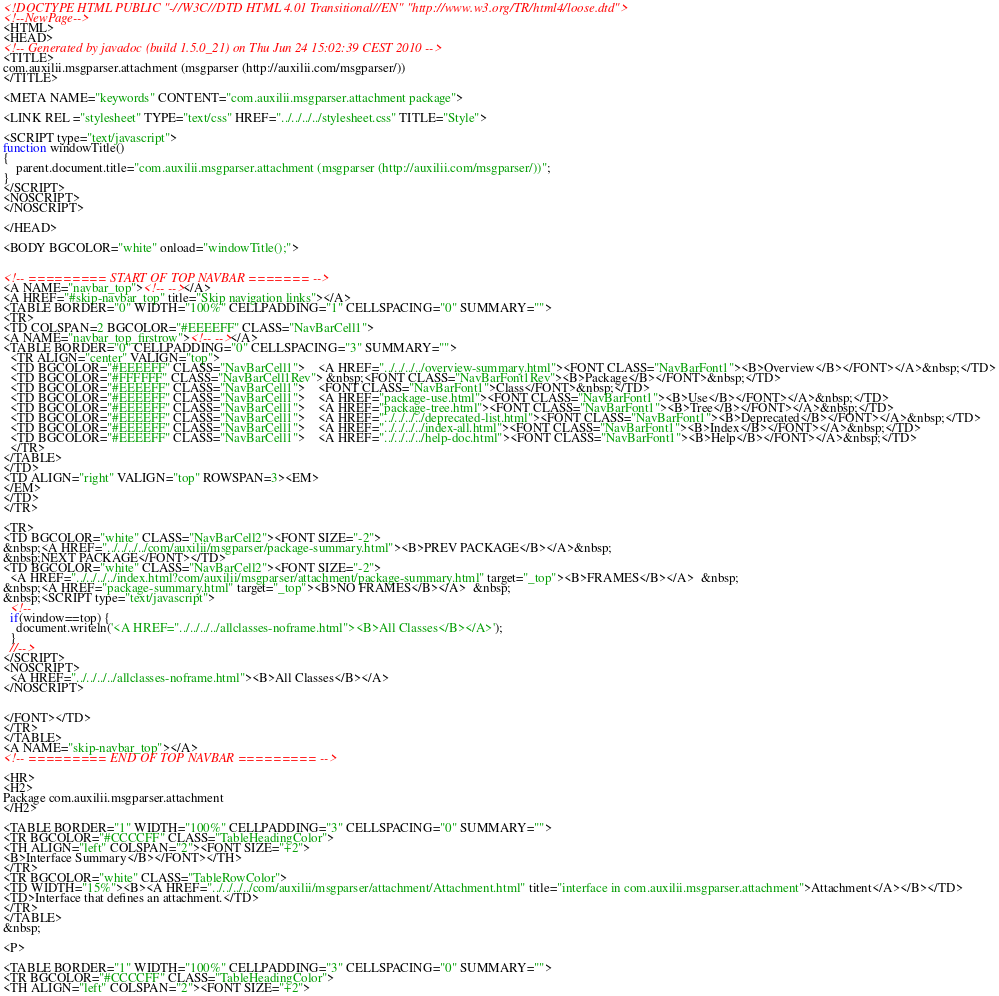<code> <loc_0><loc_0><loc_500><loc_500><_HTML_><!DOCTYPE HTML PUBLIC "-//W3C//DTD HTML 4.01 Transitional//EN" "http://www.w3.org/TR/html4/loose.dtd">
<!--NewPage-->
<HTML>
<HEAD>
<!-- Generated by javadoc (build 1.5.0_21) on Thu Jun 24 15:02:39 CEST 2010 -->
<TITLE>
com.auxilii.msgparser.attachment (msgparser (http://auxilii.com/msgparser/))
</TITLE>

<META NAME="keywords" CONTENT="com.auxilii.msgparser.attachment package">

<LINK REL ="stylesheet" TYPE="text/css" HREF="../../../../stylesheet.css" TITLE="Style">

<SCRIPT type="text/javascript">
function windowTitle()
{
    parent.document.title="com.auxilii.msgparser.attachment (msgparser (http://auxilii.com/msgparser/))";
}
</SCRIPT>
<NOSCRIPT>
</NOSCRIPT>

</HEAD>

<BODY BGCOLOR="white" onload="windowTitle();">


<!-- ========= START OF TOP NAVBAR ======= -->
<A NAME="navbar_top"><!-- --></A>
<A HREF="#skip-navbar_top" title="Skip navigation links"></A>
<TABLE BORDER="0" WIDTH="100%" CELLPADDING="1" CELLSPACING="0" SUMMARY="">
<TR>
<TD COLSPAN=2 BGCOLOR="#EEEEFF" CLASS="NavBarCell1">
<A NAME="navbar_top_firstrow"><!-- --></A>
<TABLE BORDER="0" CELLPADDING="0" CELLSPACING="3" SUMMARY="">
  <TR ALIGN="center" VALIGN="top">
  <TD BGCOLOR="#EEEEFF" CLASS="NavBarCell1">    <A HREF="../../../../overview-summary.html"><FONT CLASS="NavBarFont1"><B>Overview</B></FONT></A>&nbsp;</TD>
  <TD BGCOLOR="#FFFFFF" CLASS="NavBarCell1Rev"> &nbsp;<FONT CLASS="NavBarFont1Rev"><B>Package</B></FONT>&nbsp;</TD>
  <TD BGCOLOR="#EEEEFF" CLASS="NavBarCell1">    <FONT CLASS="NavBarFont1">Class</FONT>&nbsp;</TD>
  <TD BGCOLOR="#EEEEFF" CLASS="NavBarCell1">    <A HREF="package-use.html"><FONT CLASS="NavBarFont1"><B>Use</B></FONT></A>&nbsp;</TD>
  <TD BGCOLOR="#EEEEFF" CLASS="NavBarCell1">    <A HREF="package-tree.html"><FONT CLASS="NavBarFont1"><B>Tree</B></FONT></A>&nbsp;</TD>
  <TD BGCOLOR="#EEEEFF" CLASS="NavBarCell1">    <A HREF="../../../../deprecated-list.html"><FONT CLASS="NavBarFont1"><B>Deprecated</B></FONT></A>&nbsp;</TD>
  <TD BGCOLOR="#EEEEFF" CLASS="NavBarCell1">    <A HREF="../../../../index-all.html"><FONT CLASS="NavBarFont1"><B>Index</B></FONT></A>&nbsp;</TD>
  <TD BGCOLOR="#EEEEFF" CLASS="NavBarCell1">    <A HREF="../../../../help-doc.html"><FONT CLASS="NavBarFont1"><B>Help</B></FONT></A>&nbsp;</TD>
  </TR>
</TABLE>
</TD>
<TD ALIGN="right" VALIGN="top" ROWSPAN=3><EM>
</EM>
</TD>
</TR>

<TR>
<TD BGCOLOR="white" CLASS="NavBarCell2"><FONT SIZE="-2">
&nbsp;<A HREF="../../../../com/auxilii/msgparser/package-summary.html"><B>PREV PACKAGE</B></A>&nbsp;
&nbsp;NEXT PACKAGE</FONT></TD>
<TD BGCOLOR="white" CLASS="NavBarCell2"><FONT SIZE="-2">
  <A HREF="../../../../index.html?com/auxilii/msgparser/attachment/package-summary.html" target="_top"><B>FRAMES</B></A>  &nbsp;
&nbsp;<A HREF="package-summary.html" target="_top"><B>NO FRAMES</B></A>  &nbsp;
&nbsp;<SCRIPT type="text/javascript">
  <!--
  if(window==top) {
    document.writeln('<A HREF="../../../../allclasses-noframe.html"><B>All Classes</B></A>');
  }
  //-->
</SCRIPT>
<NOSCRIPT>
  <A HREF="../../../../allclasses-noframe.html"><B>All Classes</B></A>
</NOSCRIPT>


</FONT></TD>
</TR>
</TABLE>
<A NAME="skip-navbar_top"></A>
<!-- ========= END OF TOP NAVBAR ========= -->

<HR>
<H2>
Package com.auxilii.msgparser.attachment
</H2>

<TABLE BORDER="1" WIDTH="100%" CELLPADDING="3" CELLSPACING="0" SUMMARY="">
<TR BGCOLOR="#CCCCFF" CLASS="TableHeadingColor">
<TH ALIGN="left" COLSPAN="2"><FONT SIZE="+2">
<B>Interface Summary</B></FONT></TH>
</TR>
<TR BGCOLOR="white" CLASS="TableRowColor">
<TD WIDTH="15%"><B><A HREF="../../../../com/auxilii/msgparser/attachment/Attachment.html" title="interface in com.auxilii.msgparser.attachment">Attachment</A></B></TD>
<TD>Interface that defines an attachment.</TD>
</TR>
</TABLE>
&nbsp;

<P>

<TABLE BORDER="1" WIDTH="100%" CELLPADDING="3" CELLSPACING="0" SUMMARY="">
<TR BGCOLOR="#CCCCFF" CLASS="TableHeadingColor">
<TH ALIGN="left" COLSPAN="2"><FONT SIZE="+2"></code> 